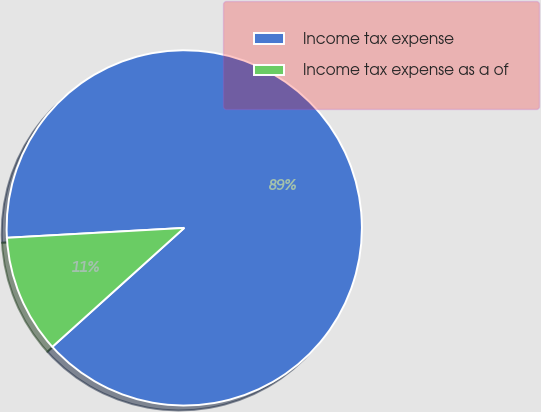Convert chart to OTSL. <chart><loc_0><loc_0><loc_500><loc_500><pie_chart><fcel>Income tax expense<fcel>Income tax expense as a of<nl><fcel>89.21%<fcel>10.79%<nl></chart> 